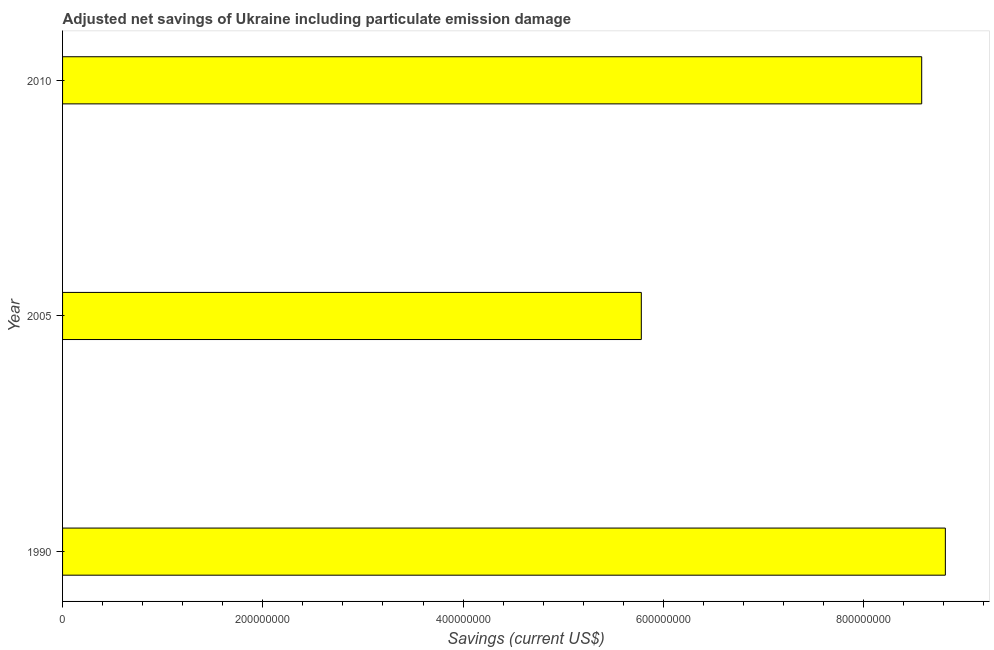Does the graph contain grids?
Your answer should be very brief. No. What is the title of the graph?
Offer a very short reply. Adjusted net savings of Ukraine including particulate emission damage. What is the label or title of the X-axis?
Your response must be concise. Savings (current US$). What is the label or title of the Y-axis?
Your answer should be compact. Year. What is the adjusted net savings in 2010?
Your response must be concise. 8.58e+08. Across all years, what is the maximum adjusted net savings?
Keep it short and to the point. 8.82e+08. Across all years, what is the minimum adjusted net savings?
Provide a short and direct response. 5.78e+08. What is the sum of the adjusted net savings?
Keep it short and to the point. 2.32e+09. What is the difference between the adjusted net savings in 2005 and 2010?
Your answer should be very brief. -2.80e+08. What is the average adjusted net savings per year?
Provide a succinct answer. 7.73e+08. What is the median adjusted net savings?
Make the answer very short. 8.58e+08. What is the ratio of the adjusted net savings in 2005 to that in 2010?
Your response must be concise. 0.67. Is the adjusted net savings in 1990 less than that in 2005?
Provide a succinct answer. No. What is the difference between the highest and the second highest adjusted net savings?
Keep it short and to the point. 2.36e+07. What is the difference between the highest and the lowest adjusted net savings?
Your answer should be very brief. 3.04e+08. In how many years, is the adjusted net savings greater than the average adjusted net savings taken over all years?
Keep it short and to the point. 2. How many bars are there?
Make the answer very short. 3. Are all the bars in the graph horizontal?
Your response must be concise. Yes. What is the difference between two consecutive major ticks on the X-axis?
Provide a succinct answer. 2.00e+08. Are the values on the major ticks of X-axis written in scientific E-notation?
Your answer should be compact. No. What is the Savings (current US$) in 1990?
Provide a short and direct response. 8.82e+08. What is the Savings (current US$) in 2005?
Your response must be concise. 5.78e+08. What is the Savings (current US$) of 2010?
Keep it short and to the point. 8.58e+08. What is the difference between the Savings (current US$) in 1990 and 2005?
Your answer should be compact. 3.04e+08. What is the difference between the Savings (current US$) in 1990 and 2010?
Offer a terse response. 2.36e+07. What is the difference between the Savings (current US$) in 2005 and 2010?
Provide a succinct answer. -2.80e+08. What is the ratio of the Savings (current US$) in 1990 to that in 2005?
Offer a very short reply. 1.52. What is the ratio of the Savings (current US$) in 1990 to that in 2010?
Your answer should be very brief. 1.03. What is the ratio of the Savings (current US$) in 2005 to that in 2010?
Provide a succinct answer. 0.67. 